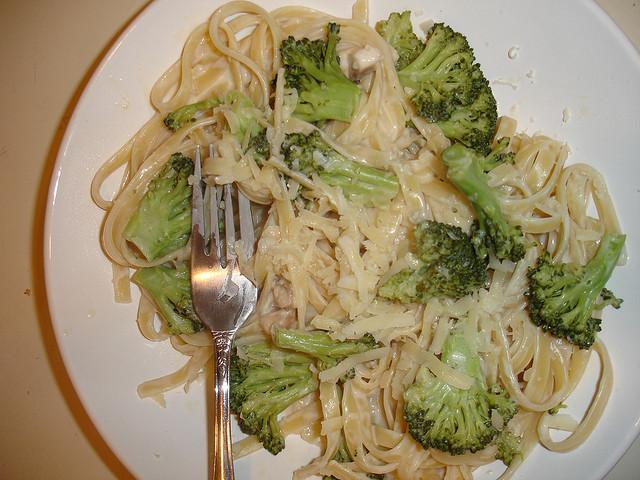How many broccolis are visible?
Give a very brief answer. 10. How many zebras walking by?
Give a very brief answer. 0. 